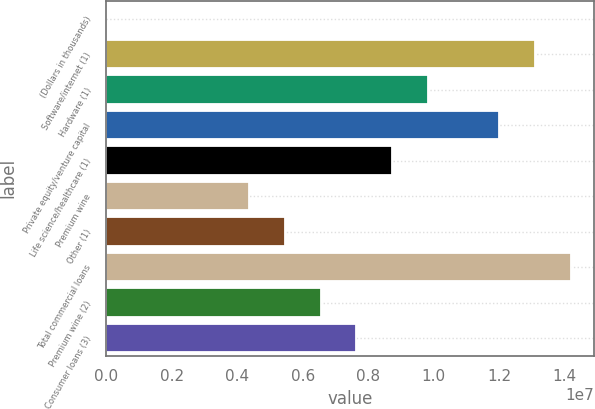<chart> <loc_0><loc_0><loc_500><loc_500><bar_chart><fcel>(Dollars in thousands)<fcel>Software/internet (1)<fcel>Hardware (1)<fcel>Private equity/venture capital<fcel>Life science/healthcare (1)<fcel>Premium wine<fcel>Other (1)<fcel>Total commercial loans<fcel>Premium wine (2)<fcel>Consumer loans (3)<nl><fcel>2013<fcel>1.30873e+07<fcel>9.81595e+06<fcel>1.19968e+07<fcel>8.72551e+06<fcel>4.36376e+06<fcel>5.4542e+06<fcel>1.41777e+07<fcel>6.54464e+06<fcel>7.63507e+06<nl></chart> 